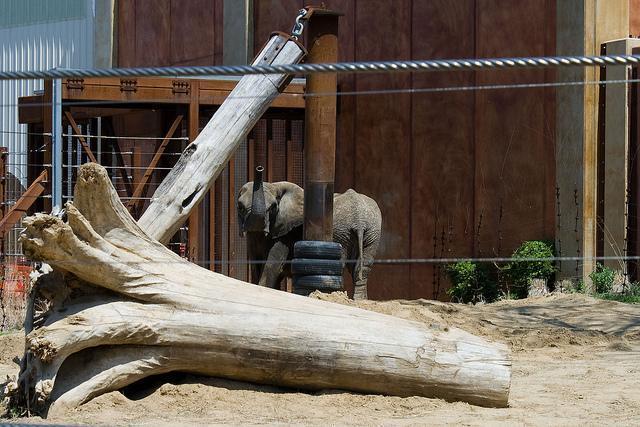How many elephants can be seen?
Give a very brief answer. 2. 